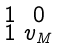<formula> <loc_0><loc_0><loc_500><loc_500>\begin{smallmatrix} 1 & 0 \\ 1 & v _ { M } \end{smallmatrix}</formula> 